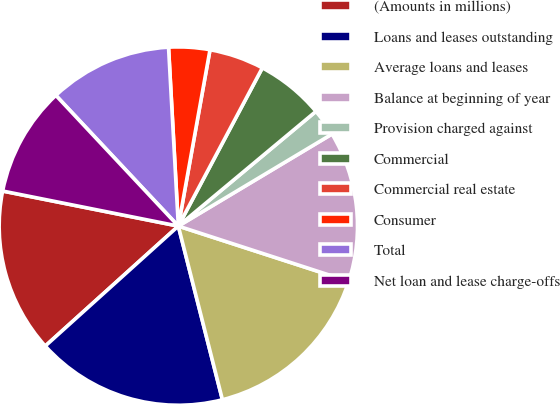<chart> <loc_0><loc_0><loc_500><loc_500><pie_chart><fcel>(Amounts in millions)<fcel>Loans and leases outstanding<fcel>Average loans and leases<fcel>Balance at beginning of year<fcel>Provision charged against<fcel>Commercial<fcel>Commercial real estate<fcel>Consumer<fcel>Total<fcel>Net loan and lease charge-offs<nl><fcel>14.81%<fcel>17.28%<fcel>16.05%<fcel>13.58%<fcel>2.47%<fcel>6.17%<fcel>4.94%<fcel>3.7%<fcel>11.11%<fcel>9.88%<nl></chart> 